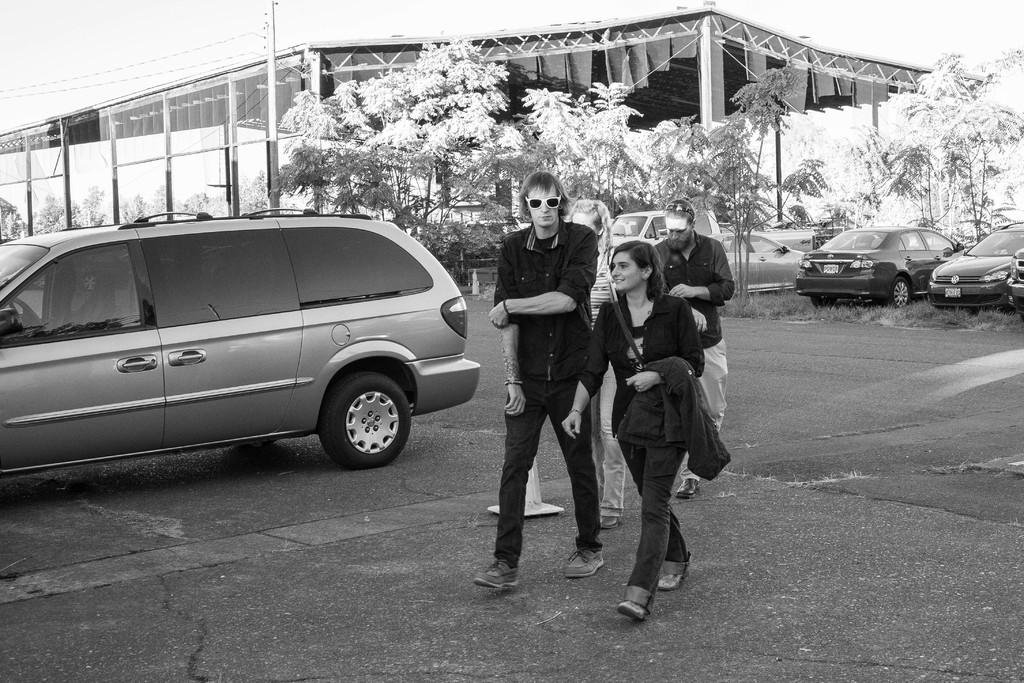What are the people in the image doing? There is a group of people walking in the image. What can be seen in the background of the image? There are vehicles, trees, and a shed in the background of the image. What is the color scheme of the image? The image is in black and white. Where is the volleyball court located in the image? There is no volleyball court present in the image. What type of haircut is the person in the image getting? There are no people getting a haircut in the image. 